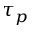Convert formula to latex. <formula><loc_0><loc_0><loc_500><loc_500>\tau _ { p }</formula> 